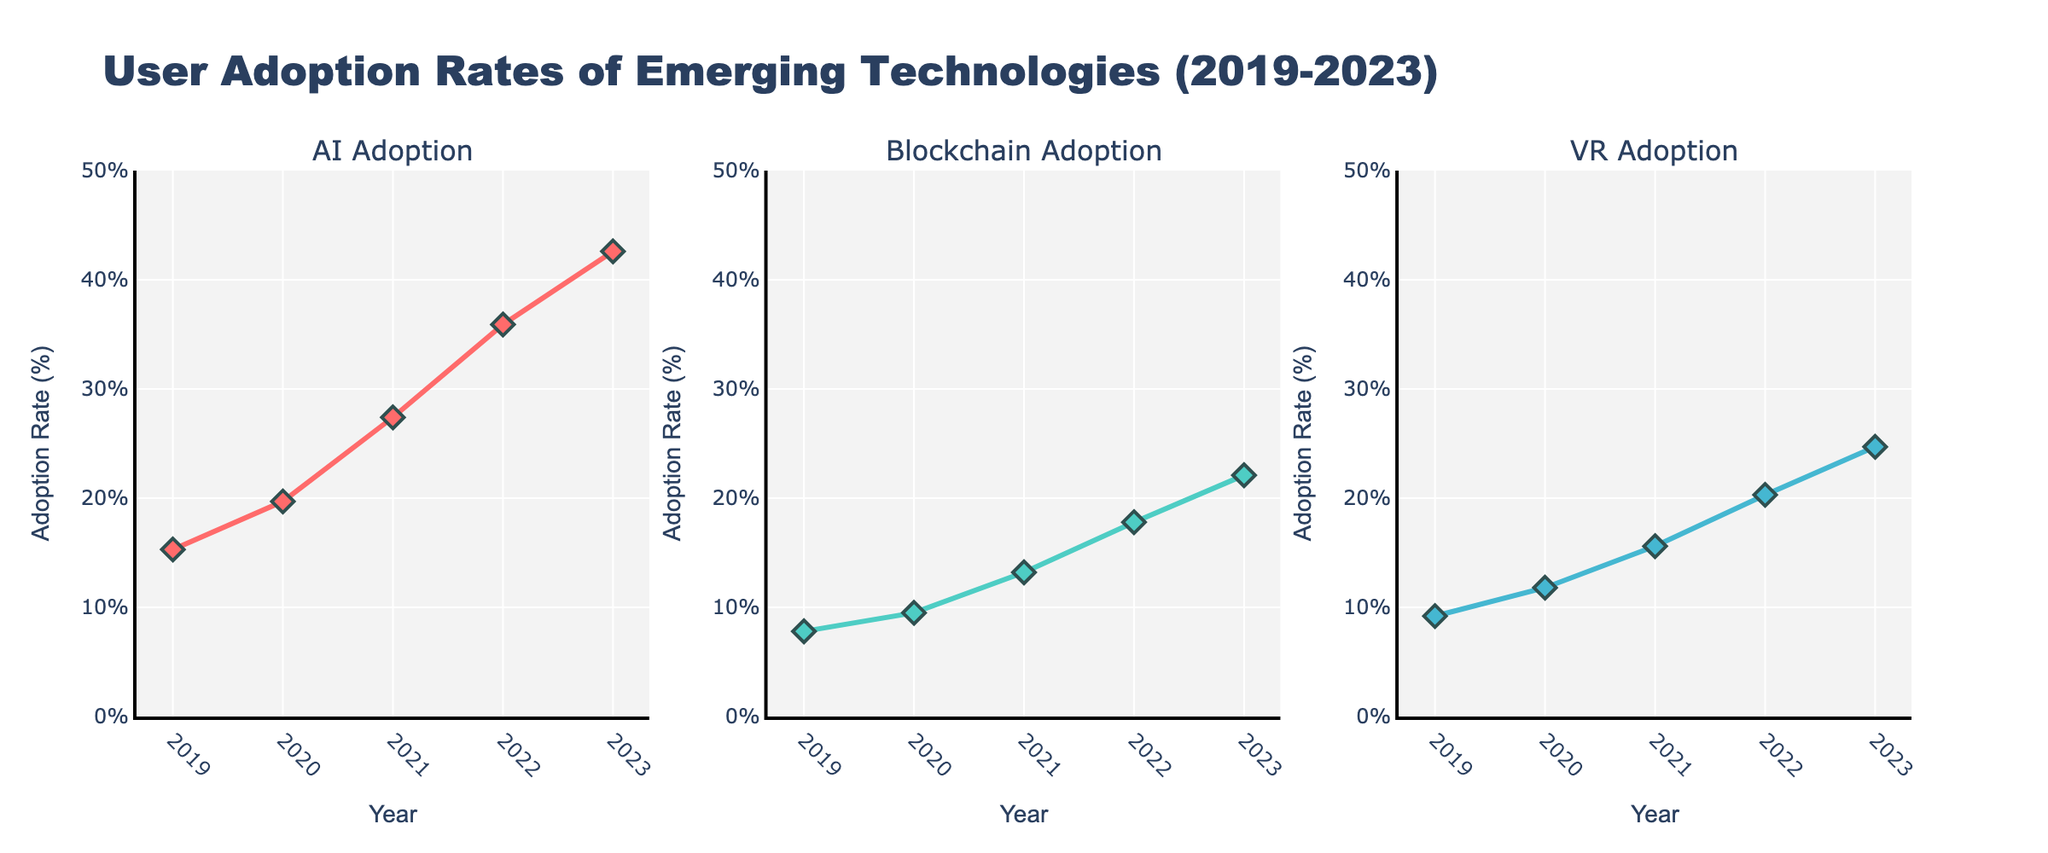Which emerging technology had the highest adoption rate in 2023? The y-axis values at 2023 indicate the adoption rate for AI as 42.6%, Blockchain as 22.1%, and VR as 24.7%. AI has the highest adoption rate.
Answer: AI How does the adoption rate of Blockchain in 2022 compare to that of VR in 2022? The graph shows that in 2022, Blockchain adoption was at 17.8% and VR adoption was at 20.3%. VR adoption was higher than Blockchain adoption.
Answer: VR was higher What was the trend for AI adoption rates from 2019 to 2023? The line for AI adoption rates consistently rises from 15.3% in 2019 to 42.6% in 2023, indicating a consistent upward trend.
Answer: Consistently rising Which technology showed the largest increase in adoption rate between 2021 and 2023? AI increased from 27.4% to 42.6% (15.2%), Blockchain from 13.2% to 22.1% (8.9%), and VR from 15.6% to 24.7% (9.1%). AI had the largest increase.
Answer: AI In what year did VR adoption rate surpass Blockchain adoption rate? By looking at the points where the VR and Blockchain lines intersect, VR adoption rate starts to be higher than Blockchain's in 2020.
Answer: 2020 What is the average adoption rate of AI across the 5 years? Sum of AI adoption rates from 2019 to 2023 is (15.3 + 19.7 + 27.4 + 35.9 + 42.6 = 140.9). Dividing by 5 years gives 140.9 / 5 = 28.18%.
Answer: 28.18% How many percentage points did the adoption rate of VR increase from 2019 to 2023? The VR adoption rate in 2019 was 9.2% and increased to 24.7% in 2023. The increase is 24.7 - 9.2 = 15.5 percentage points.
Answer: 15.5 Identify the year with the steepest increase in AI adoption rate. The increase in AI adoption is highest between 2021 (27.4%) and 2022 (35.9%), with an increase of 35.9 - 27.4 = 8.5 percentage points.
Answer: 2021 to 2022 What is the total increase in the adoption rate of Blockchain from 2019 to 2023? Blockchain adoption increased from 7.8% in 2019 to 22.1% in 2023. The total increase is 22.1 - 7.8 = 14.3 percentage points.
Answer: 14.3 